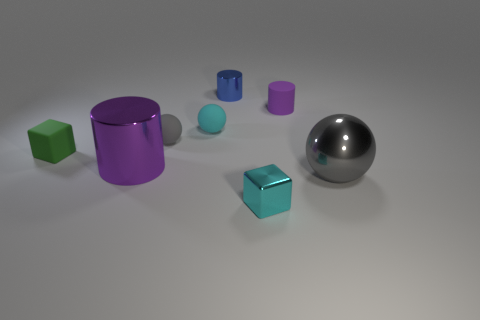Are there the same number of cyan blocks that are left of the small cyan matte ball and blocks that are in front of the tiny cyan shiny block?
Provide a succinct answer. Yes. What number of other objects are the same color as the tiny metallic cube?
Your answer should be compact. 1. Does the large sphere have the same color as the tiny ball in front of the small cyan ball?
Offer a very short reply. Yes. How many purple objects are either big cylinders or small rubber cylinders?
Your answer should be very brief. 2. Are there an equal number of gray balls behind the cyan shiny cube and small matte balls?
Give a very brief answer. Yes. There is another small thing that is the same shape as the green object; what color is it?
Provide a succinct answer. Cyan. What number of cyan things have the same shape as the small green rubber object?
Give a very brief answer. 1. There is another cylinder that is the same color as the matte cylinder; what is its material?
Your answer should be very brief. Metal. How many tiny gray things are there?
Ensure brevity in your answer.  1. Are there any tiny gray things that have the same material as the small green block?
Ensure brevity in your answer.  Yes. 